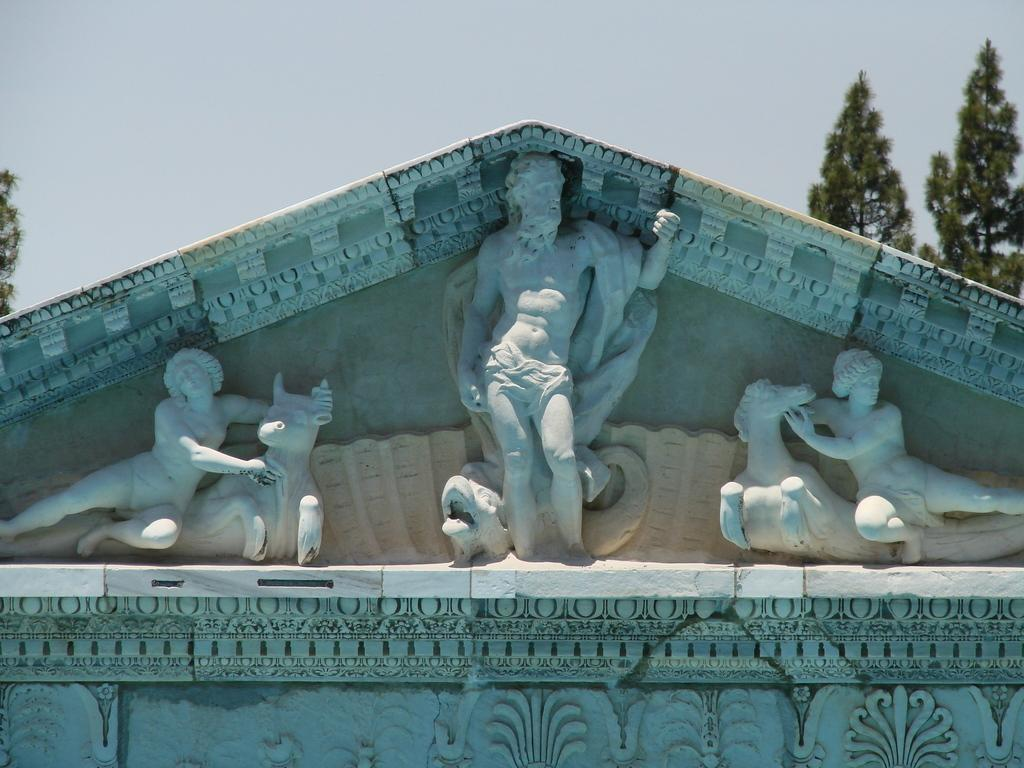What type of structure is shown in the image? The image is of a building. What decorative elements can be seen on the building? There are sculptures on the wall of the building. What natural elements are visible near the building? There are trees visible at the back of the building. What is visible at the top of the image? The sky is visible at the top of the image. Can you tell me how many skateboards are leaning against the wall of the building in the image? There are no skateboards present in the image; the only objects mentioned are the building, sculptures, trees, and sky. What type of oil can be seen dripping from the sculptures on the wall of the building in the image? There is no oil present in the image; the sculptures are not described as having any liquid or substance dripping from them. 